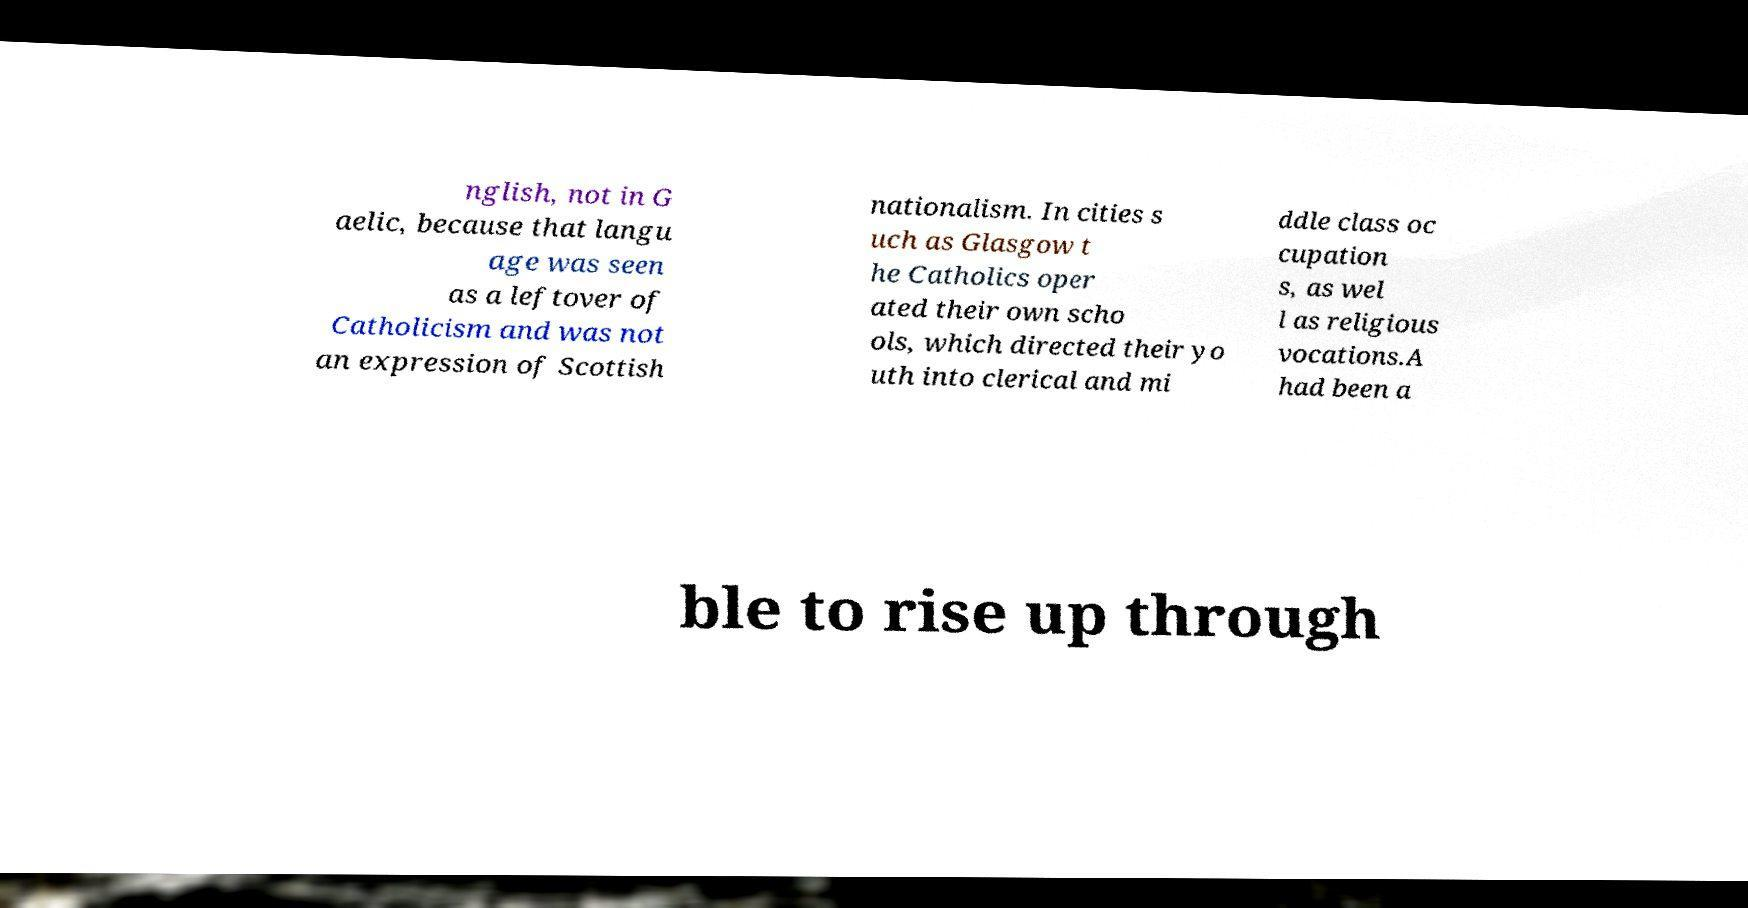Could you assist in decoding the text presented in this image and type it out clearly? nglish, not in G aelic, because that langu age was seen as a leftover of Catholicism and was not an expression of Scottish nationalism. In cities s uch as Glasgow t he Catholics oper ated their own scho ols, which directed their yo uth into clerical and mi ddle class oc cupation s, as wel l as religious vocations.A had been a ble to rise up through 